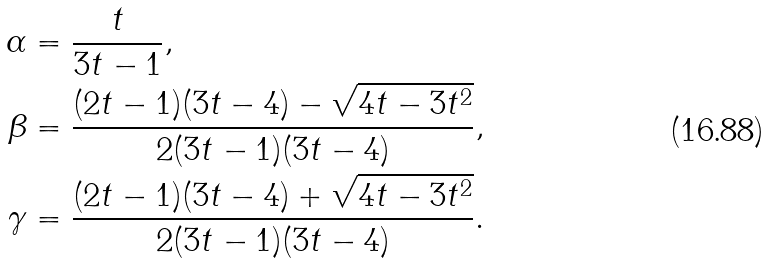Convert formula to latex. <formula><loc_0><loc_0><loc_500><loc_500>\alpha & = \frac { t } { 3 t - 1 } , \\ \beta & = \frac { ( 2 t - 1 ) ( 3 t - 4 ) - \sqrt { 4 t - 3 t ^ { 2 } } } { 2 ( 3 t - 1 ) ( 3 t - 4 ) } , \\ \gamma & = \frac { ( 2 t - 1 ) ( 3 t - 4 ) + \sqrt { 4 t - 3 t ^ { 2 } } } { 2 ( 3 t - 1 ) ( 3 t - 4 ) } .</formula> 